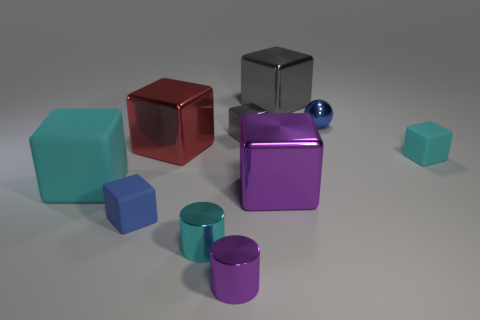Subtract all purple blocks. How many blocks are left? 6 Subtract all tiny blue matte blocks. How many blocks are left? 6 Subtract 0 blue cylinders. How many objects are left? 10 Subtract all blocks. How many objects are left? 3 Subtract 1 cylinders. How many cylinders are left? 1 Subtract all green cubes. Subtract all blue cylinders. How many cubes are left? 7 Subtract all yellow cylinders. How many green blocks are left? 0 Subtract all gray metallic things. Subtract all blue metal things. How many objects are left? 7 Add 7 big purple things. How many big purple things are left? 8 Add 10 brown shiny cylinders. How many brown shiny cylinders exist? 10 